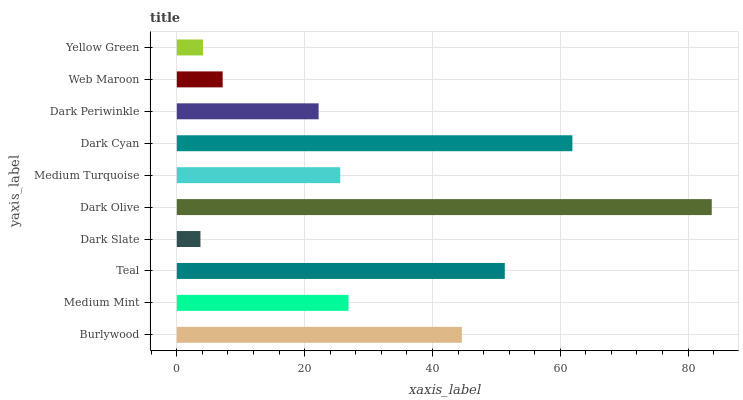Is Dark Slate the minimum?
Answer yes or no. Yes. Is Dark Olive the maximum?
Answer yes or no. Yes. Is Medium Mint the minimum?
Answer yes or no. No. Is Medium Mint the maximum?
Answer yes or no. No. Is Burlywood greater than Medium Mint?
Answer yes or no. Yes. Is Medium Mint less than Burlywood?
Answer yes or no. Yes. Is Medium Mint greater than Burlywood?
Answer yes or no. No. Is Burlywood less than Medium Mint?
Answer yes or no. No. Is Medium Mint the high median?
Answer yes or no. Yes. Is Medium Turquoise the low median?
Answer yes or no. Yes. Is Yellow Green the high median?
Answer yes or no. No. Is Dark Slate the low median?
Answer yes or no. No. 